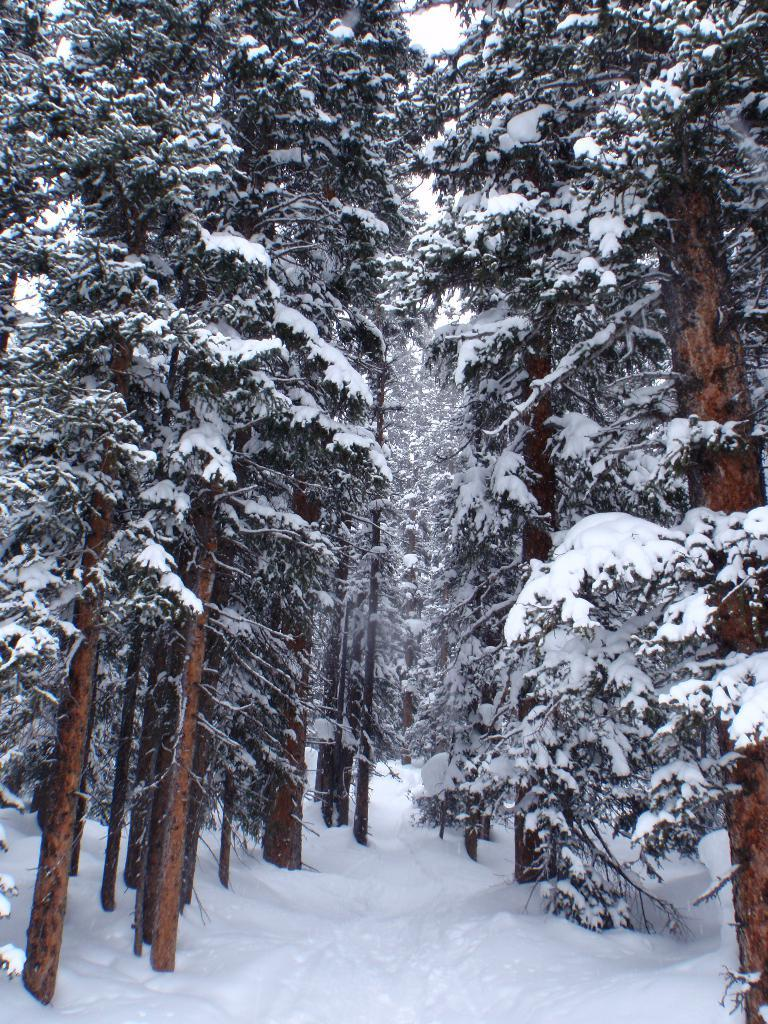What type of vegetation can be seen in the image? There are trees in the image. What is covering the trees in the image? The trees have snow on them. What is visible at the bottom of the image? There is snow visible at the bottom of the image. What type of fuel is being used to power the vest in the image? There is no vest or fuel present in the image; it features trees with snow on them and snow at the bottom. 